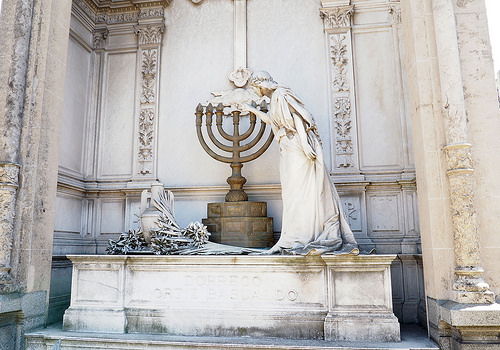<image>
Is the statue on the vase? No. The statue is not positioned on the vase. They may be near each other, but the statue is not supported by or resting on top of the vase. 